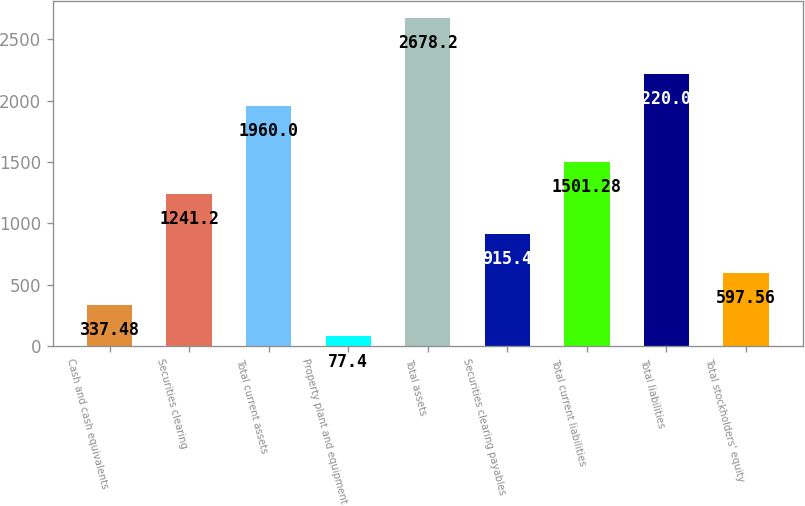Convert chart. <chart><loc_0><loc_0><loc_500><loc_500><bar_chart><fcel>Cash and cash equivalents<fcel>Securities clearing<fcel>Total current assets<fcel>Property plant and equipment<fcel>Total assets<fcel>Securities clearing payables<fcel>Total current liabilities<fcel>Total liabilities<fcel>Total stockholders' equity<nl><fcel>337.48<fcel>1241.2<fcel>1960<fcel>77.4<fcel>2678.2<fcel>915.4<fcel>1501.28<fcel>2220.08<fcel>597.56<nl></chart> 